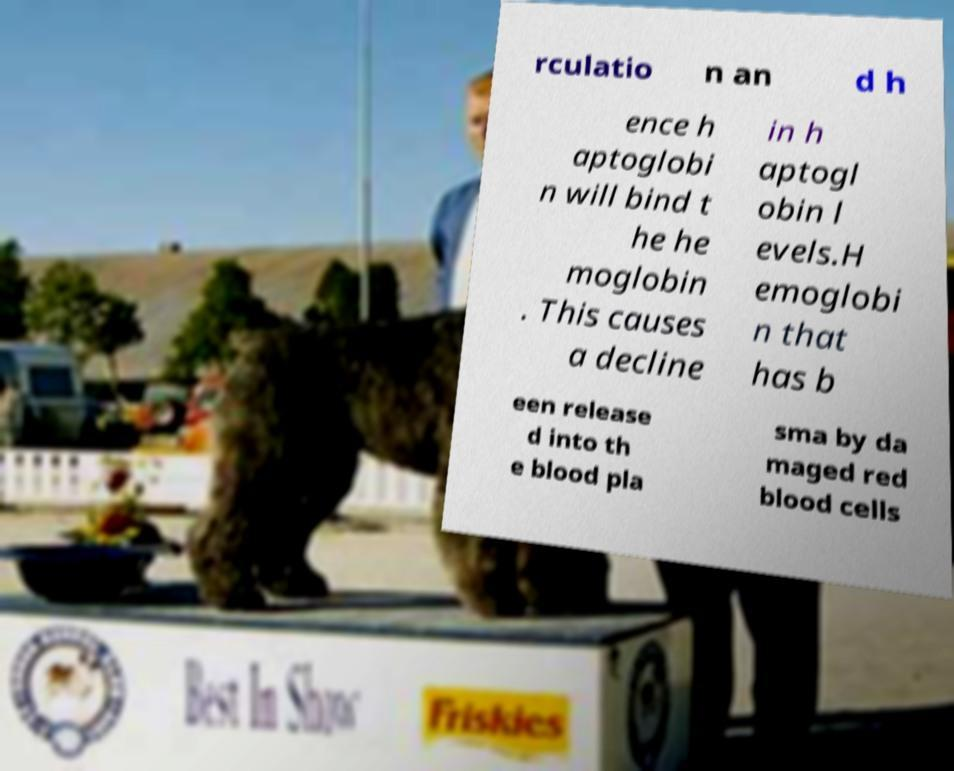I need the written content from this picture converted into text. Can you do that? rculatio n an d h ence h aptoglobi n will bind t he he moglobin . This causes a decline in h aptogl obin l evels.H emoglobi n that has b een release d into th e blood pla sma by da maged red blood cells 